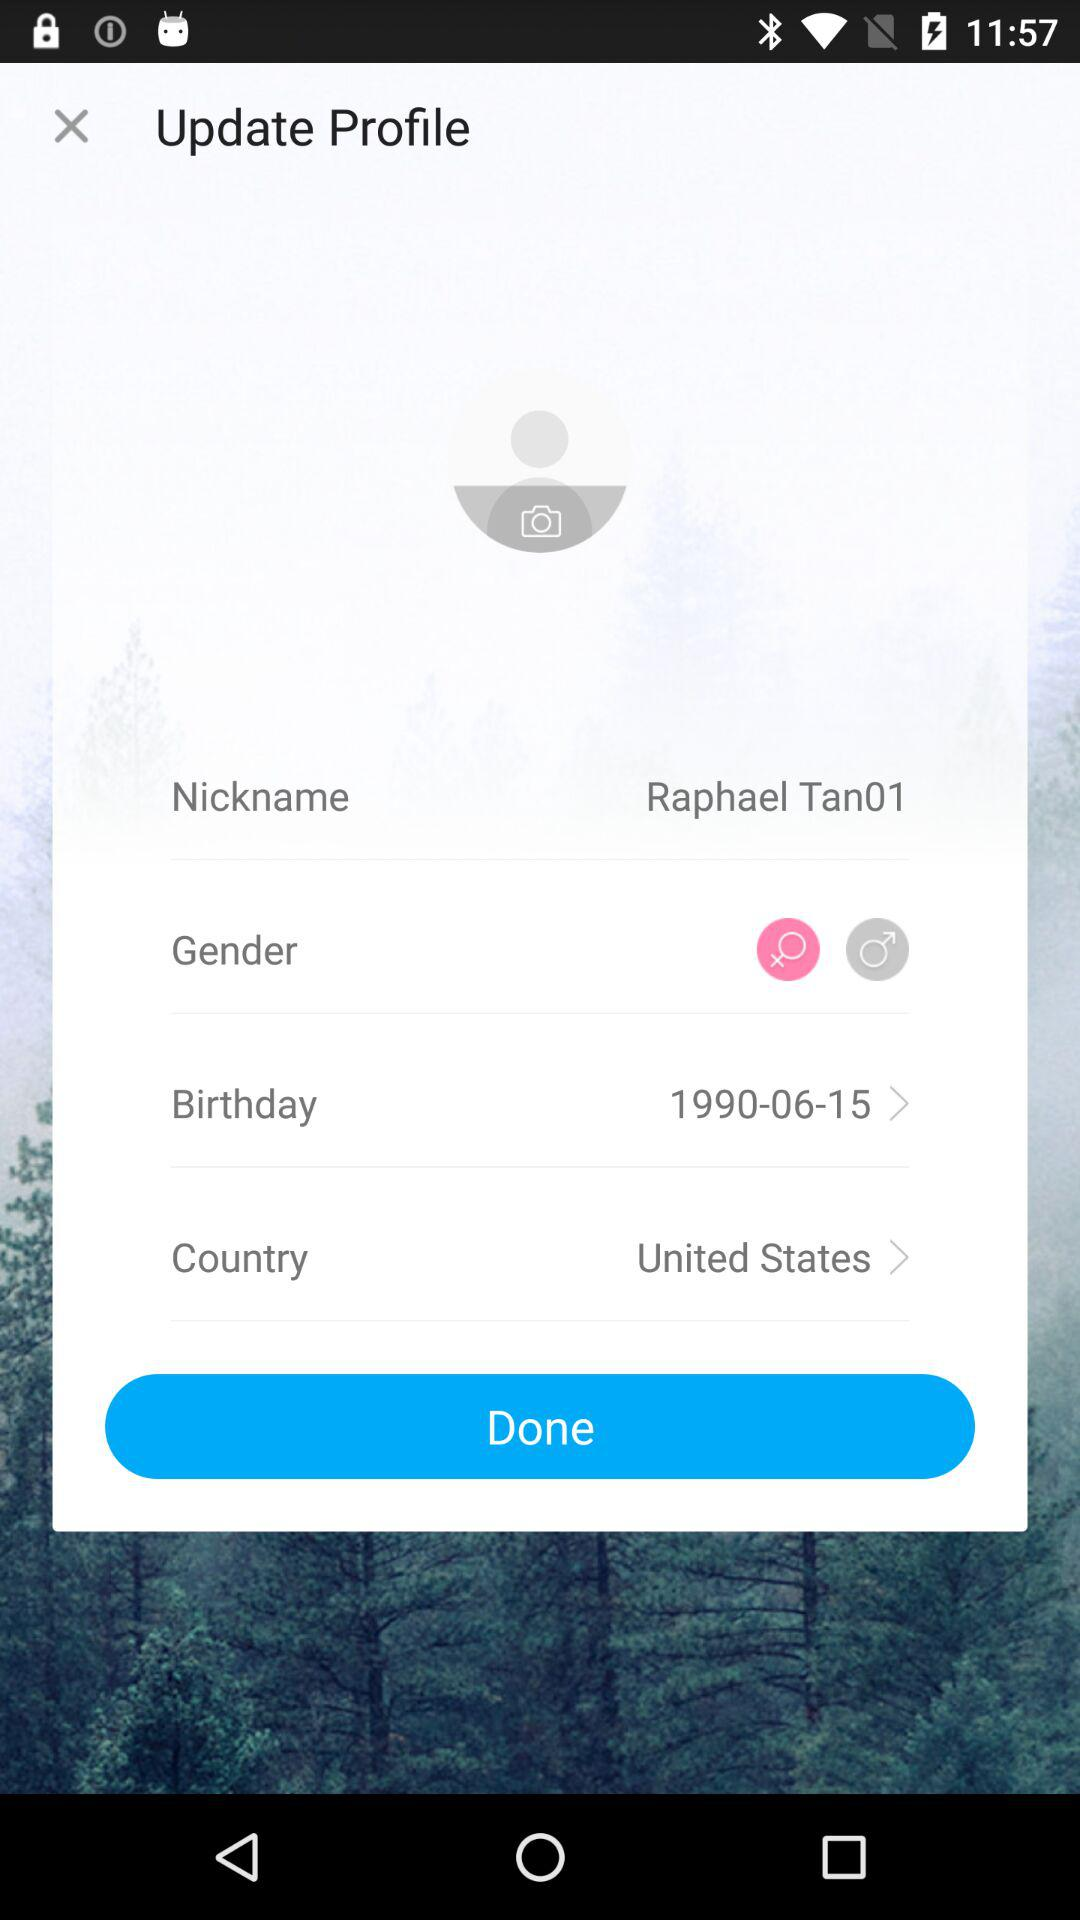What is the date of birth? The date of birth is June 15, 1990. 